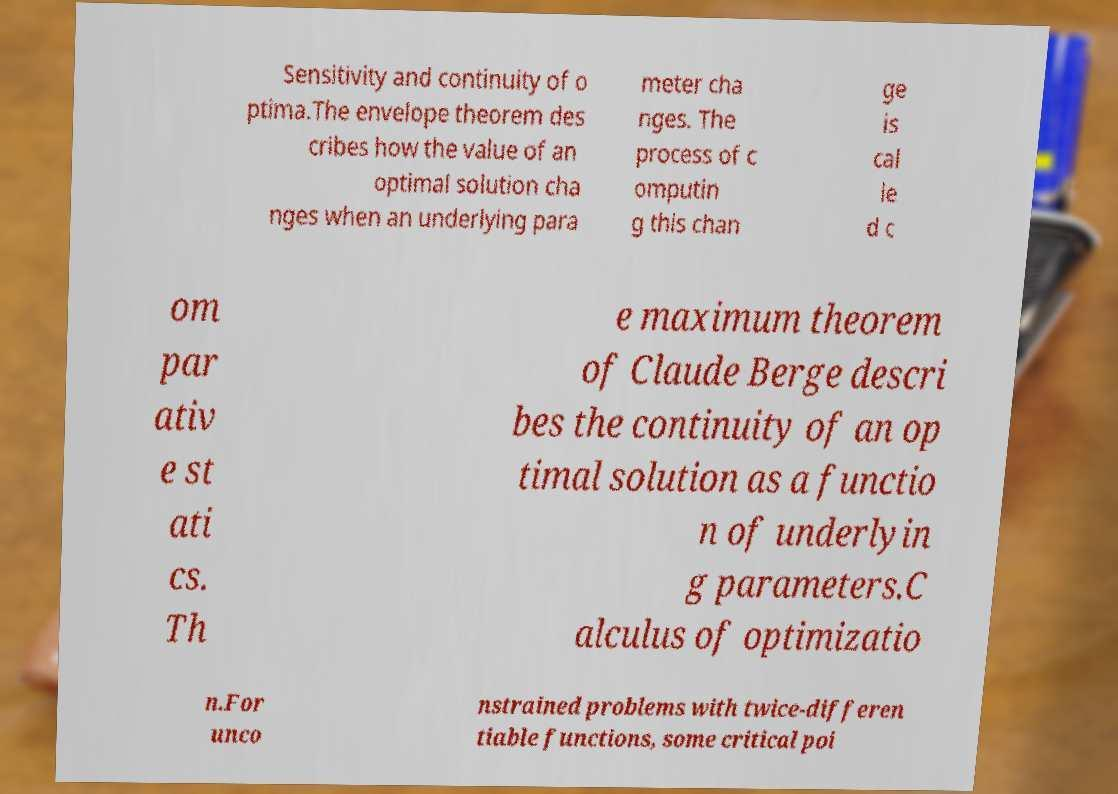I need the written content from this picture converted into text. Can you do that? Sensitivity and continuity of o ptima.The envelope theorem des cribes how the value of an optimal solution cha nges when an underlying para meter cha nges. The process of c omputin g this chan ge is cal le d c om par ativ e st ati cs. Th e maximum theorem of Claude Berge descri bes the continuity of an op timal solution as a functio n of underlyin g parameters.C alculus of optimizatio n.For unco nstrained problems with twice-differen tiable functions, some critical poi 